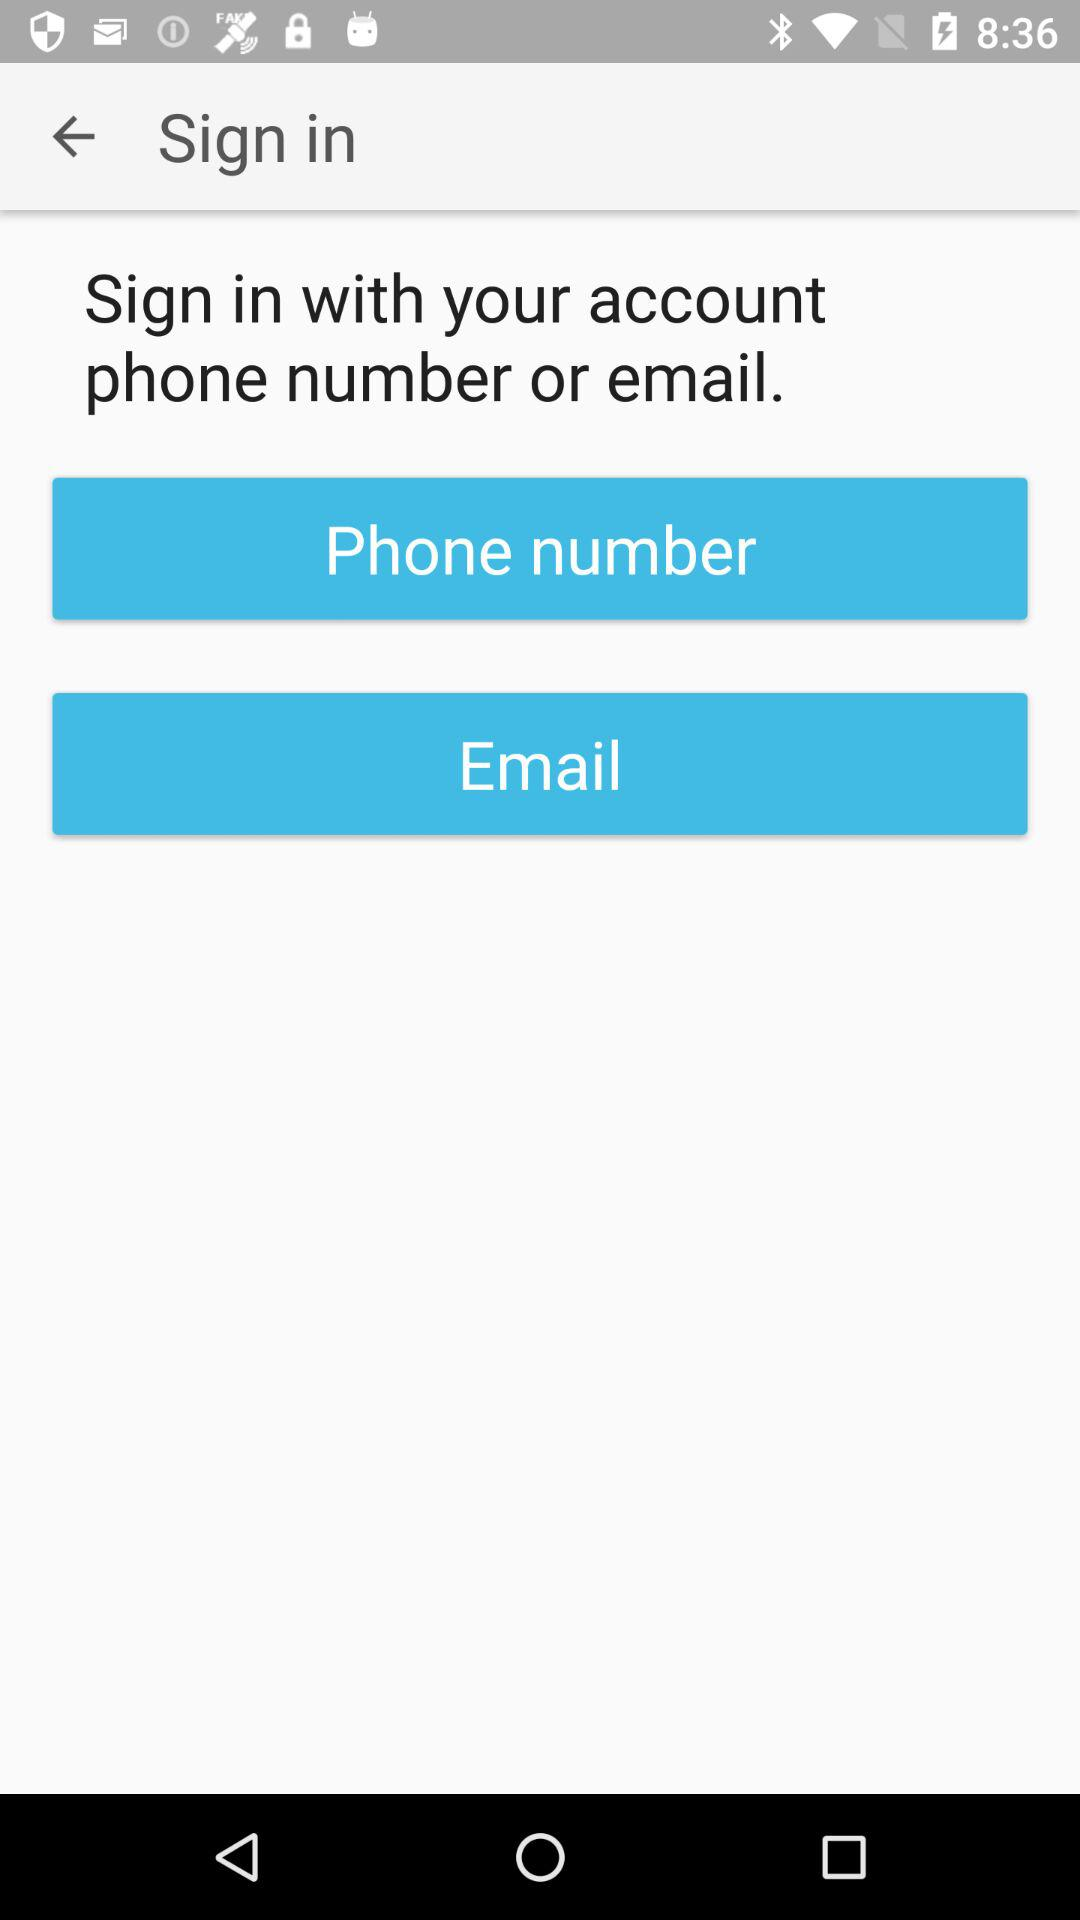What options can I use to sign in? You can use "Phone number" and "Email" to sign in. 